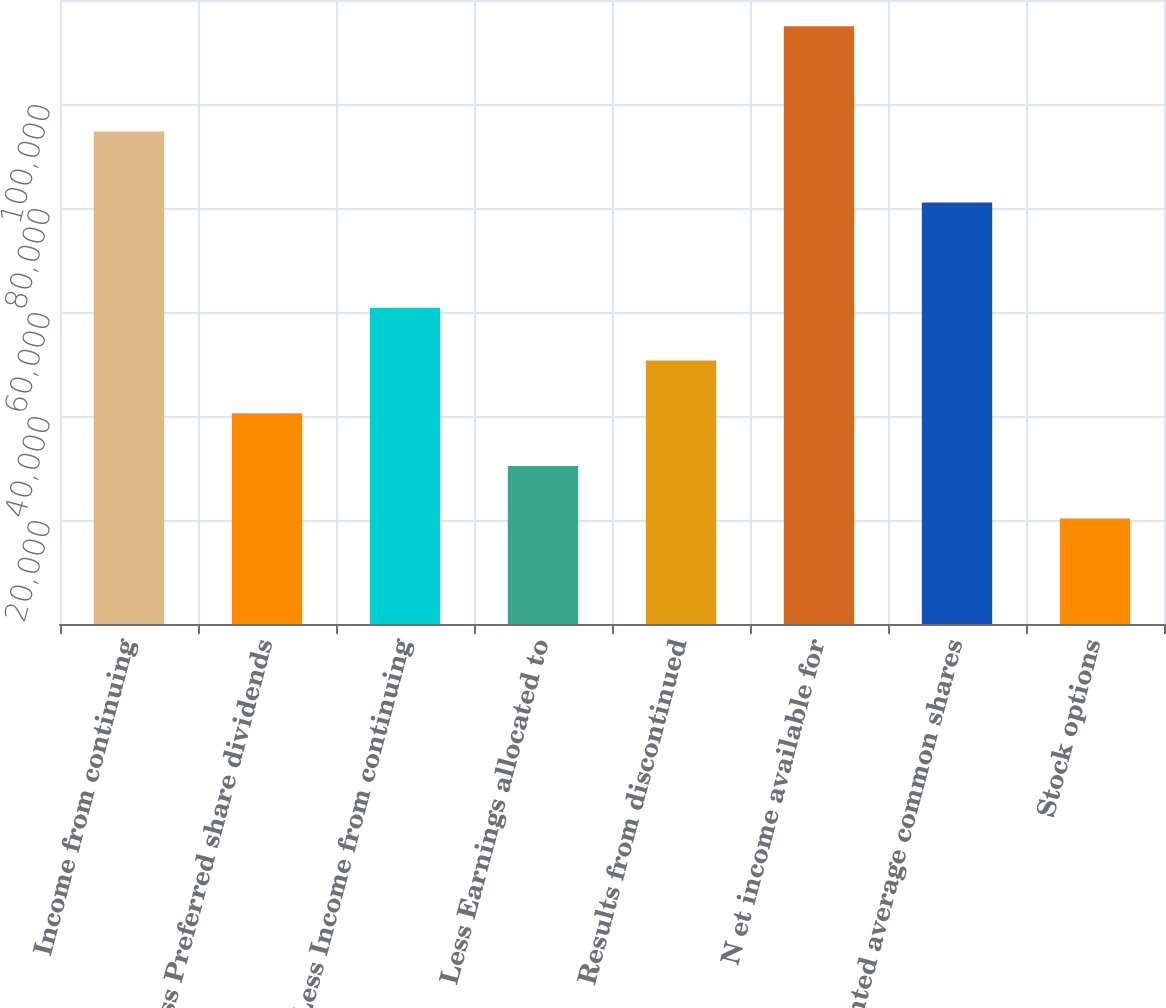Convert chart. <chart><loc_0><loc_0><loc_500><loc_500><bar_chart><fcel>Income from continuing<fcel>Less Preferred share dividends<fcel>Less Income from continuing<fcel>Less Earnings allocated to<fcel>Results from discontinued<fcel>N et income available for<fcel>Weighted average common shares<fcel>Stock options<nl><fcel>94706<fcel>40530<fcel>60795<fcel>30397.5<fcel>50662.5<fcel>114971<fcel>81060<fcel>20265<nl></chart> 